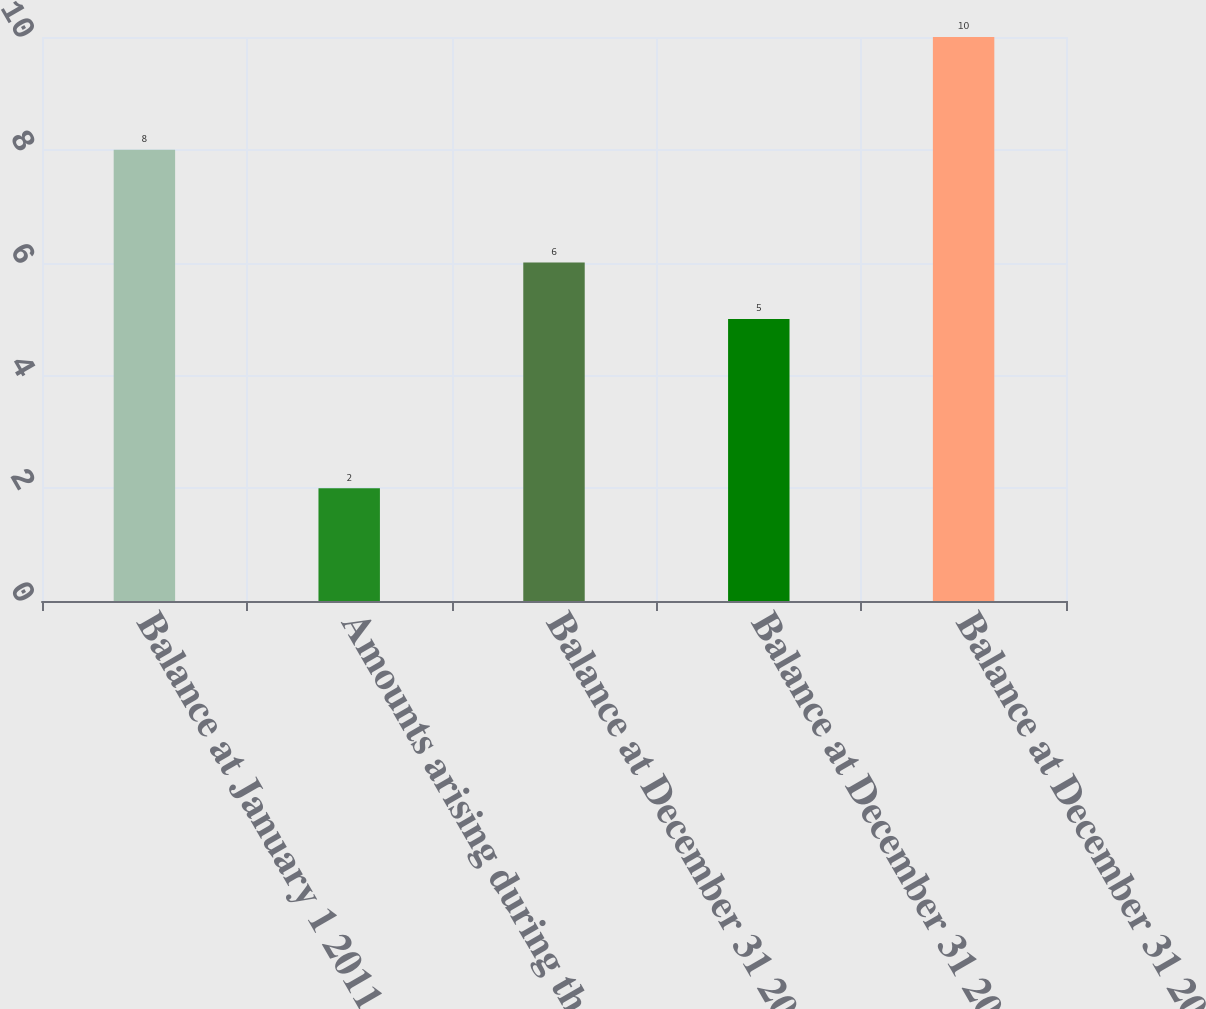Convert chart to OTSL. <chart><loc_0><loc_0><loc_500><loc_500><bar_chart><fcel>Balance at January 1 2011<fcel>Amounts arising during the<fcel>Balance at December 31 2011<fcel>Balance at December 31 2012<fcel>Balance at December 31 2013<nl><fcel>8<fcel>2<fcel>6<fcel>5<fcel>10<nl></chart> 